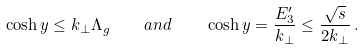<formula> <loc_0><loc_0><loc_500><loc_500>\cosh y \leq k _ { \perp } \Lambda _ { g } \quad a n d \quad \cosh y = \frac { E ^ { \prime } _ { 3 } } { k _ { \perp } } \leq \frac { \sqrt { s } } { 2 k _ { \perp } } \, .</formula> 